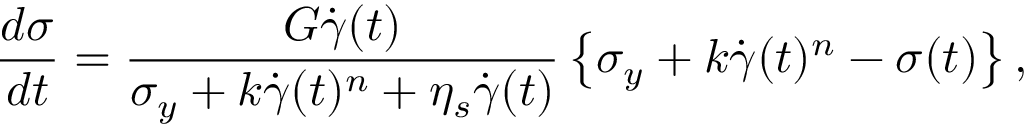Convert formula to latex. <formula><loc_0><loc_0><loc_500><loc_500>\frac { d \sigma } { d t } = \frac { G \dot { \gamma } ( t ) } { \sigma _ { y } + k \dot { \gamma } ( t ) ^ { n } + \eta _ { s } \dot { \gamma } ( t ) } \left \{ \sigma _ { y } + k \dot { \gamma } ( t ) ^ { n } - \sigma ( t ) \right \} ,</formula> 